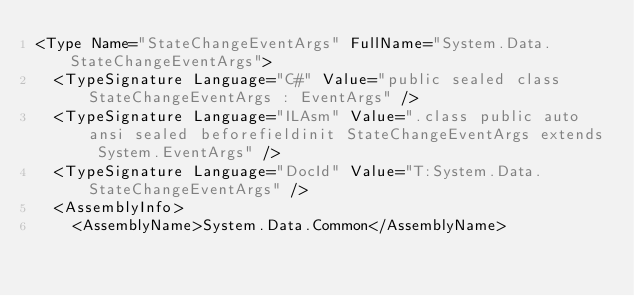Convert code to text. <code><loc_0><loc_0><loc_500><loc_500><_XML_><Type Name="StateChangeEventArgs" FullName="System.Data.StateChangeEventArgs">
  <TypeSignature Language="C#" Value="public sealed class StateChangeEventArgs : EventArgs" />
  <TypeSignature Language="ILAsm" Value=".class public auto ansi sealed beforefieldinit StateChangeEventArgs extends System.EventArgs" />
  <TypeSignature Language="DocId" Value="T:System.Data.StateChangeEventArgs" />
  <AssemblyInfo>
    <AssemblyName>System.Data.Common</AssemblyName></code> 